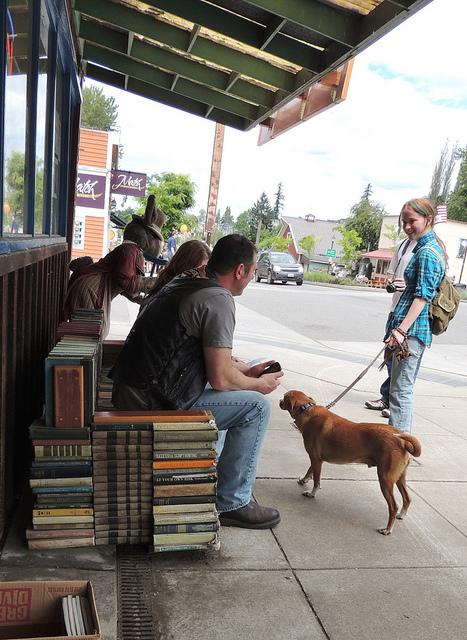Why are they sitting on a pile of books? Please explain your reasoning. is bookstore. They're at a bookstore. 